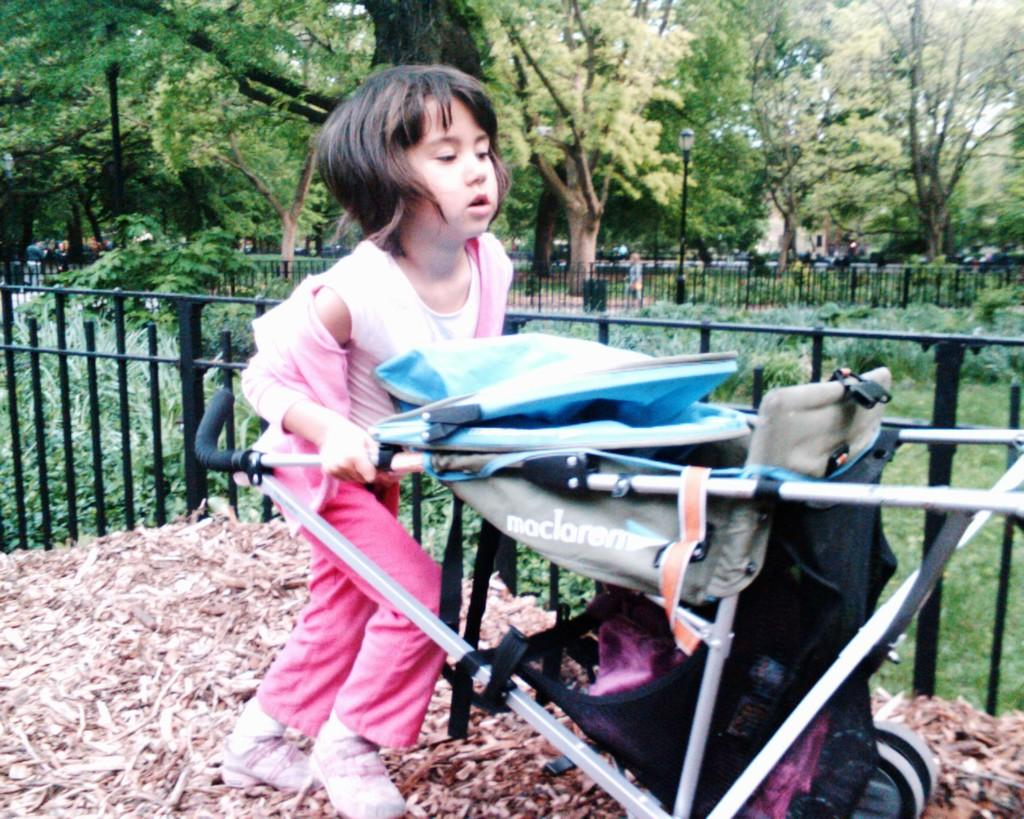Who is the main subject in the image? There is a girl in the image. What is the girl doing in the image? The girl is pushing a stroller with her hands. What can be seen in the background of the image? There are fences, plants, trees, a person standing on the ground, a building, and the sky visible in the background of the image. What type of knife is the girl using to cut the plants in the image? There is no knife present in the image, and the girl is not cutting any plants. 